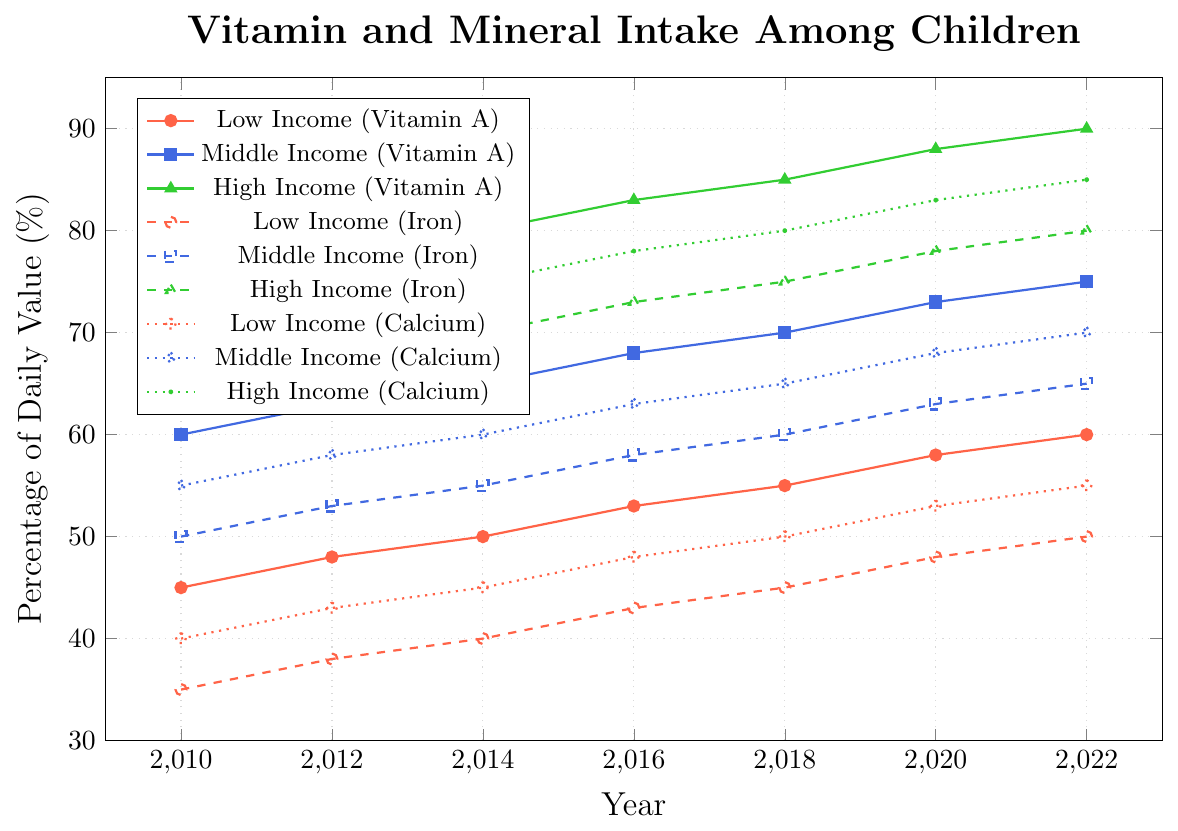What's the general trend for Vitamin A intake over time among the three income groups? Each income group's Vitamin A intake shows an upward trend over time (from 2010 to 2022), with low income starting at 45% DV and reaching 60%, middle income starting at 60% DV and reaching 75%, and high income starting at 75% DV and reaching 90%.
Answer: Upward trend Which income group had the lowest Iron intake in 2016? By observing the Iron intake lines, the low-income group had the lowest Iron intake in 2016 at 43% DV, compared to middle-income at 58% DV and high-income at 73% DV.
Answer: Low-income group Is there a year when Vitamin A intake for the low-income group is higher than Iron intake for the middle-income group? Yes, from the chart, in 2020, Vitamin A intake for the low-income group is 58% DV and Iron intake for the middle-income group is 63% DV, so this is not true. However, in 2022, Vitamin A intake for the low-income group is 60% DV, whereas Iron intake for the middle-income group is 65% – no higher year can be found based on the plot.
Answer: No What is the range of Calcium intake for the high-income group from 2010 to 2022? The range is the difference between the highest and lowest intake levels. For the high-income group, Calcium intake starts at 70% DV in 2010 and ends at 85% DV in 2022. The range is 85% - 70% = 15%.
Answer: 15% How does Calcium intake for low-income children in 2022 compare to that for middle-income children in 2016? Calcium intake for low-income children in 2022 is 55% DV, whereas for middle-income children in 2016, it is 63% DV. Therefore, Calcium intake for low-income is lower than middle-income in those years.
Answer: Lower How much did Vitamin A intake for middle-income children increase from 2010 to 2022? The increase is the difference between the intake in 2022 and 2010. For middle-income children, Vitamin A intake increased from 60% DV in 2010 to 75% DV in 2022. Thus, the increase is 75% - 60% = 15%.
Answer: 15% In which year did high-income children achieve at least 80% DV of Vitamin A? To determine this, check when Vitamin A intake for high-income children first reaches 80%. The chart shows that this level is first achieved in 2014.
Answer: 2014 How does the trend of Iron intake for low-income and middle-income groups compare? Both low-income and middle-income groups show a consistent upward trend in Iron intake over time from 2010 to 2022. Low-income intake increases from 35% DV to 50%, and middle-income intake increases from 50% DV to 65%.
Answer: Both upward In which years did Children from high-income families have over 80% DV intake for all three nutrients? Review each nutrient for high-income children. They have over 80% DV for Vitamin A, Iron, and Calcium from 2016 to 2022.
Answer: 2016-2022 